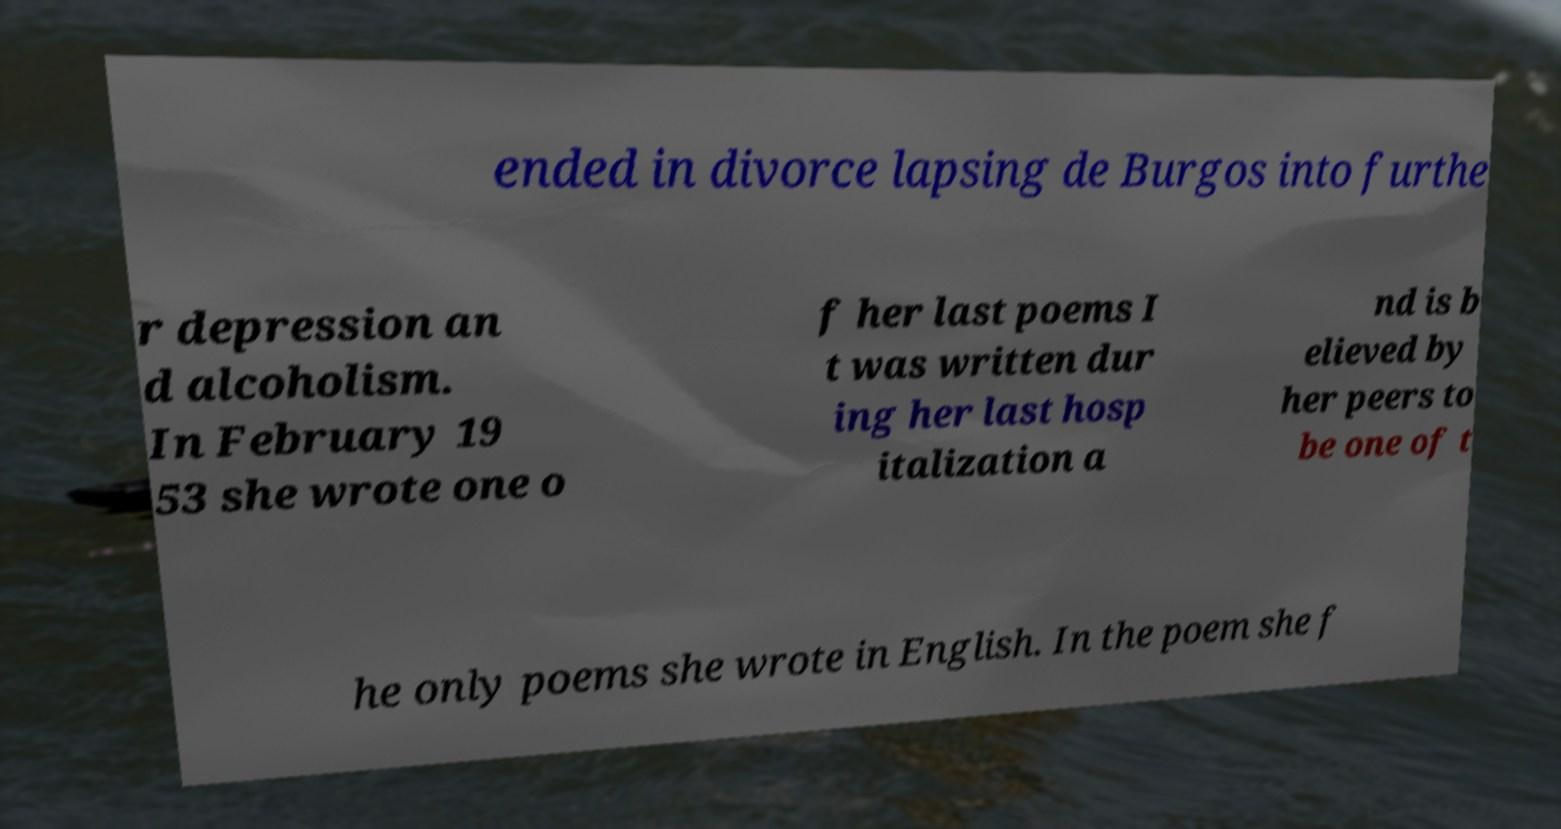What messages or text are displayed in this image? I need them in a readable, typed format. ended in divorce lapsing de Burgos into furthe r depression an d alcoholism. In February 19 53 she wrote one o f her last poems I t was written dur ing her last hosp italization a nd is b elieved by her peers to be one of t he only poems she wrote in English. In the poem she f 